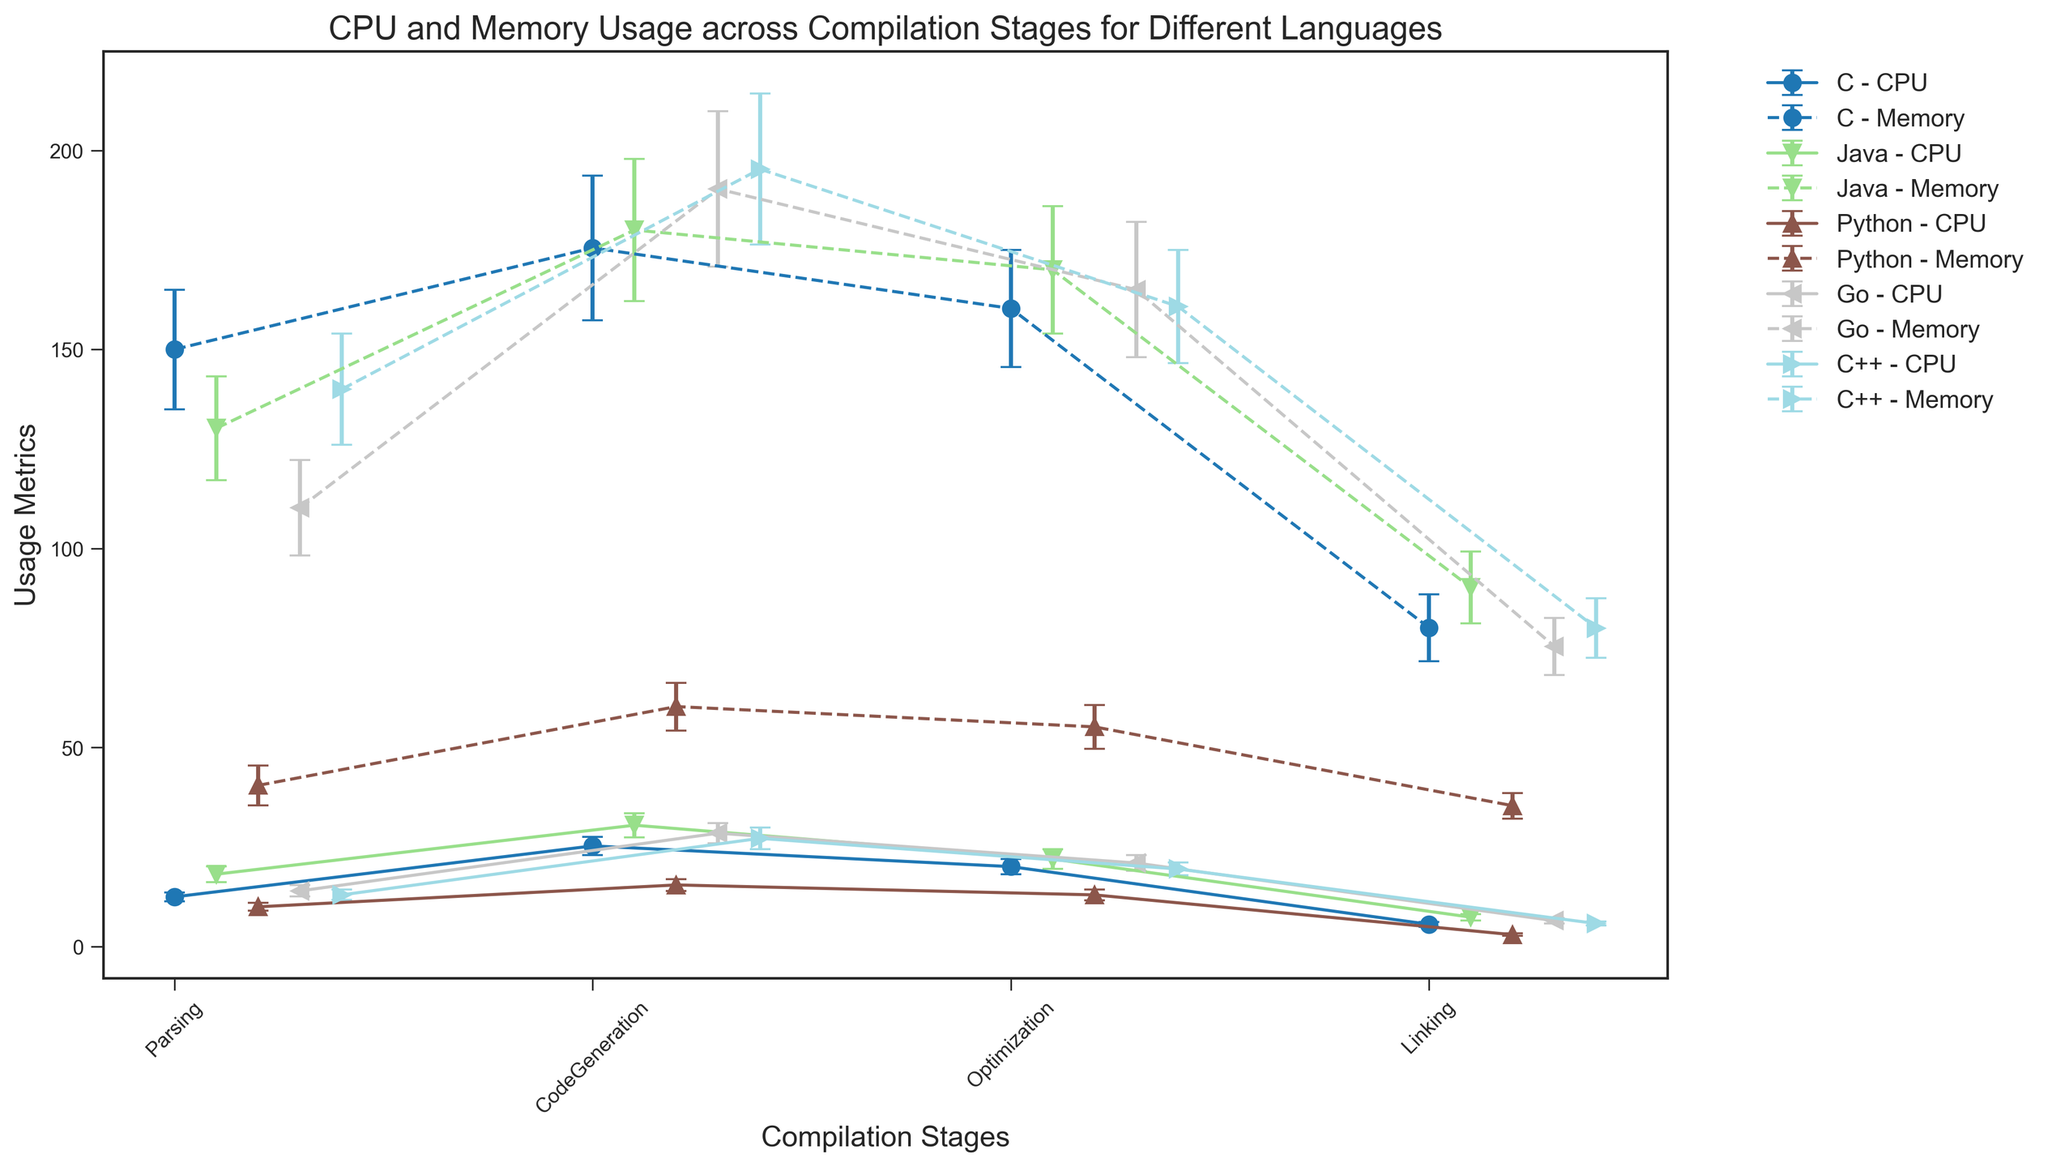What is the difference in mean CPU usage between the Parsing stage of C and Java? The mean CPU usage of C during the Parsing stage is 12.5 and for Java, it is 18.2. The difference is calculated as 18.2 - 12.5.
Answer: 5.7 Which programming language has the highest mean memory usage during the CodeGeneration stage? During the CodeGeneration stage, Python has a mean memory usage of 60.3, C has 175.5, Java has 180.0, Go has 190.3, and C++ has 195.3. Hence, C++ has the highest mean memory usage during this stage.
Answer: C++ Between Java and Go, which language exhibits lower mean CPU usage in Optimization? The mean CPU usage for the Optimization stage in Java is 22.0 while for Go, it is 21.0. Hence, Go exhibits lower mean CPU usage.
Answer: Go Considering the Linking stage, what is the average mean memory usage across all programming languages? To get the average mean memory usage for the Linking stage: (C's 80.1 + Java's 90.2 + Python's 35.4 + Go's 75.4 + C++'s 80.0) / 5 = (80.1 + 90.2 + 35.4 + 75.4 + 80) / 5 = 361.1 / 5 = 72.22.
Answer: 72.22 For which stage does Python show the least variation (standard deviation) in memory usage? The standard deviations for memory usage in Python across stages are Parsing: 5.0, CodeGeneration: 6.0, Optimization: 5.5, Linking: 3.2. The least variation in memory usage is 3.2 during the Linking stage.
Answer: Linking Which programming language shows the greatest overall mean CPU usage during the CodeGeneration stage, and what is the corresponding value? The mean CPU usage values during the CodeGeneration stage are: C: 25.3, Java: 30.5, Python: 15.5, Go: 28.5, and C++: 27.2. Therefore, Java has the greatest overall mean CPU usage of 30.5 during this stage.
Answer: Java, 30.5 What is the total mean memory usage for the Optimization stage when summing all programming languages? Sum of mean memory usage for Optimization stage: C (160.3) + Java (170.0) + Python (55.2) + Go (165.0) + C++ (160.8) = 160.3 + 170 + 55.2 + 165 + 160.8 = 711.3.
Answer: 711.3 Which language has the smallest mean CPU usage during the Linking stage, and by how much is it smaller than the language with the second smallest mean? The mean CPU usage during the Linking stage are: C (5.6), Java (7.4), Python (3.0), Go (6.5), and C++ (5.8). Python has the smallest mean CPU usage of 3.0. The second smallest is C with 5.6. Difference is 5.6 - 3.0.
Answer: Python, 2.6 